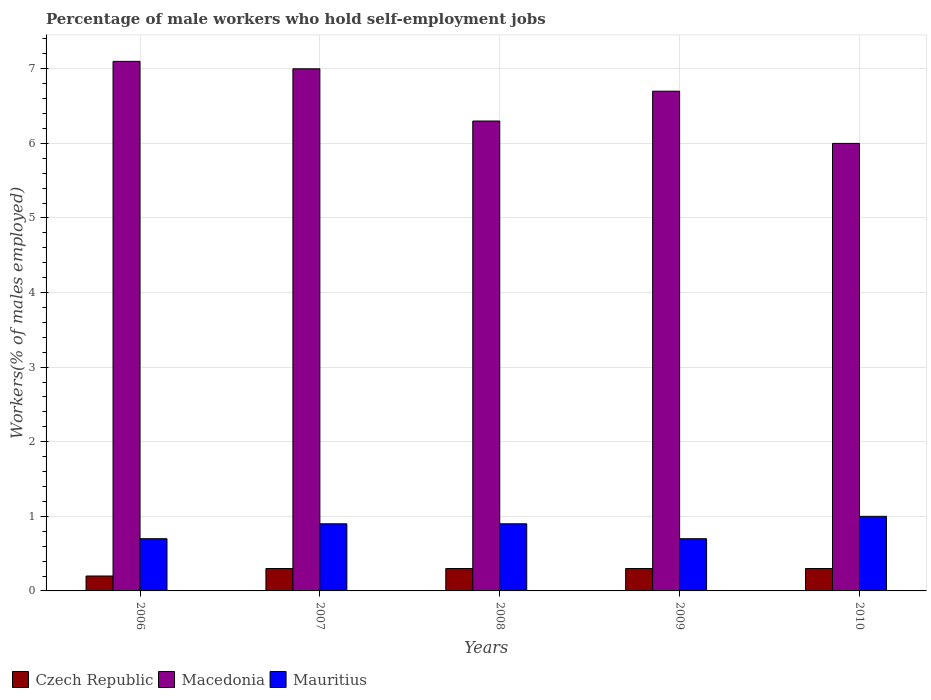How many different coloured bars are there?
Offer a very short reply. 3. Are the number of bars per tick equal to the number of legend labels?
Offer a very short reply. Yes. How many bars are there on the 3rd tick from the right?
Provide a short and direct response. 3. In how many cases, is the number of bars for a given year not equal to the number of legend labels?
Your answer should be very brief. 0. What is the percentage of self-employed male workers in Mauritius in 2009?
Give a very brief answer. 0.7. Across all years, what is the minimum percentage of self-employed male workers in Mauritius?
Your response must be concise. 0.7. In which year was the percentage of self-employed male workers in Czech Republic maximum?
Ensure brevity in your answer.  2007. In which year was the percentage of self-employed male workers in Czech Republic minimum?
Offer a terse response. 2006. What is the total percentage of self-employed male workers in Mauritius in the graph?
Ensure brevity in your answer.  4.2. What is the difference between the percentage of self-employed male workers in Czech Republic in 2006 and that in 2010?
Your response must be concise. -0.1. What is the difference between the percentage of self-employed male workers in Czech Republic in 2007 and the percentage of self-employed male workers in Macedonia in 2006?
Your answer should be compact. -6.8. What is the average percentage of self-employed male workers in Czech Republic per year?
Ensure brevity in your answer.  0.28. In the year 2006, what is the difference between the percentage of self-employed male workers in Czech Republic and percentage of self-employed male workers in Mauritius?
Keep it short and to the point. -0.5. In how many years, is the percentage of self-employed male workers in Macedonia greater than 6.4 %?
Offer a very short reply. 3. What is the ratio of the percentage of self-employed male workers in Mauritius in 2006 to that in 2010?
Your answer should be compact. 0.7. What is the difference between the highest and the lowest percentage of self-employed male workers in Macedonia?
Ensure brevity in your answer.  1.1. In how many years, is the percentage of self-employed male workers in Czech Republic greater than the average percentage of self-employed male workers in Czech Republic taken over all years?
Keep it short and to the point. 4. Is the sum of the percentage of self-employed male workers in Mauritius in 2009 and 2010 greater than the maximum percentage of self-employed male workers in Czech Republic across all years?
Give a very brief answer. Yes. What does the 1st bar from the left in 2010 represents?
Offer a terse response. Czech Republic. What does the 2nd bar from the right in 2009 represents?
Your answer should be compact. Macedonia. Is it the case that in every year, the sum of the percentage of self-employed male workers in Macedonia and percentage of self-employed male workers in Czech Republic is greater than the percentage of self-employed male workers in Mauritius?
Provide a short and direct response. Yes. How many bars are there?
Provide a succinct answer. 15. Are all the bars in the graph horizontal?
Make the answer very short. No. Are the values on the major ticks of Y-axis written in scientific E-notation?
Your response must be concise. No. Does the graph contain any zero values?
Offer a very short reply. No. How many legend labels are there?
Offer a very short reply. 3. What is the title of the graph?
Ensure brevity in your answer.  Percentage of male workers who hold self-employment jobs. What is the label or title of the Y-axis?
Your answer should be very brief. Workers(% of males employed). What is the Workers(% of males employed) of Czech Republic in 2006?
Provide a short and direct response. 0.2. What is the Workers(% of males employed) of Macedonia in 2006?
Keep it short and to the point. 7.1. What is the Workers(% of males employed) in Mauritius in 2006?
Offer a terse response. 0.7. What is the Workers(% of males employed) of Czech Republic in 2007?
Provide a short and direct response. 0.3. What is the Workers(% of males employed) of Mauritius in 2007?
Offer a terse response. 0.9. What is the Workers(% of males employed) of Czech Republic in 2008?
Give a very brief answer. 0.3. What is the Workers(% of males employed) in Macedonia in 2008?
Provide a short and direct response. 6.3. What is the Workers(% of males employed) in Mauritius in 2008?
Your answer should be compact. 0.9. What is the Workers(% of males employed) of Czech Republic in 2009?
Give a very brief answer. 0.3. What is the Workers(% of males employed) of Macedonia in 2009?
Make the answer very short. 6.7. What is the Workers(% of males employed) of Mauritius in 2009?
Give a very brief answer. 0.7. What is the Workers(% of males employed) in Czech Republic in 2010?
Offer a terse response. 0.3. What is the Workers(% of males employed) of Macedonia in 2010?
Offer a terse response. 6. What is the Workers(% of males employed) of Mauritius in 2010?
Make the answer very short. 1. Across all years, what is the maximum Workers(% of males employed) in Czech Republic?
Provide a succinct answer. 0.3. Across all years, what is the maximum Workers(% of males employed) in Macedonia?
Offer a terse response. 7.1. Across all years, what is the minimum Workers(% of males employed) in Czech Republic?
Offer a very short reply. 0.2. Across all years, what is the minimum Workers(% of males employed) in Mauritius?
Offer a very short reply. 0.7. What is the total Workers(% of males employed) in Czech Republic in the graph?
Provide a succinct answer. 1.4. What is the total Workers(% of males employed) in Macedonia in the graph?
Keep it short and to the point. 33.1. What is the total Workers(% of males employed) of Mauritius in the graph?
Your answer should be very brief. 4.2. What is the difference between the Workers(% of males employed) of Czech Republic in 2006 and that in 2007?
Provide a short and direct response. -0.1. What is the difference between the Workers(% of males employed) of Macedonia in 2006 and that in 2007?
Make the answer very short. 0.1. What is the difference between the Workers(% of males employed) of Czech Republic in 2006 and that in 2008?
Give a very brief answer. -0.1. What is the difference between the Workers(% of males employed) in Czech Republic in 2006 and that in 2009?
Make the answer very short. -0.1. What is the difference between the Workers(% of males employed) in Macedonia in 2006 and that in 2009?
Give a very brief answer. 0.4. What is the difference between the Workers(% of males employed) in Czech Republic in 2006 and that in 2010?
Offer a terse response. -0.1. What is the difference between the Workers(% of males employed) of Macedonia in 2006 and that in 2010?
Make the answer very short. 1.1. What is the difference between the Workers(% of males employed) of Mauritius in 2006 and that in 2010?
Provide a succinct answer. -0.3. What is the difference between the Workers(% of males employed) of Macedonia in 2007 and that in 2008?
Your answer should be compact. 0.7. What is the difference between the Workers(% of males employed) of Mauritius in 2007 and that in 2008?
Make the answer very short. 0. What is the difference between the Workers(% of males employed) in Czech Republic in 2007 and that in 2010?
Provide a succinct answer. 0. What is the difference between the Workers(% of males employed) in Macedonia in 2007 and that in 2010?
Provide a succinct answer. 1. What is the difference between the Workers(% of males employed) in Czech Republic in 2008 and that in 2009?
Give a very brief answer. 0. What is the difference between the Workers(% of males employed) of Macedonia in 2008 and that in 2009?
Give a very brief answer. -0.4. What is the difference between the Workers(% of males employed) in Mauritius in 2008 and that in 2009?
Keep it short and to the point. 0.2. What is the difference between the Workers(% of males employed) of Macedonia in 2008 and that in 2010?
Keep it short and to the point. 0.3. What is the difference between the Workers(% of males employed) in Czech Republic in 2006 and the Workers(% of males employed) in Macedonia in 2007?
Provide a short and direct response. -6.8. What is the difference between the Workers(% of males employed) in Czech Republic in 2006 and the Workers(% of males employed) in Mauritius in 2008?
Provide a short and direct response. -0.7. What is the difference between the Workers(% of males employed) of Czech Republic in 2006 and the Workers(% of males employed) of Macedonia in 2009?
Provide a succinct answer. -6.5. What is the difference between the Workers(% of males employed) in Czech Republic in 2006 and the Workers(% of males employed) in Mauritius in 2009?
Your response must be concise. -0.5. What is the difference between the Workers(% of males employed) of Macedonia in 2006 and the Workers(% of males employed) of Mauritius in 2009?
Give a very brief answer. 6.4. What is the difference between the Workers(% of males employed) in Czech Republic in 2006 and the Workers(% of males employed) in Mauritius in 2010?
Give a very brief answer. -0.8. What is the difference between the Workers(% of males employed) of Macedonia in 2006 and the Workers(% of males employed) of Mauritius in 2010?
Your answer should be very brief. 6.1. What is the difference between the Workers(% of males employed) in Czech Republic in 2007 and the Workers(% of males employed) in Macedonia in 2008?
Ensure brevity in your answer.  -6. What is the difference between the Workers(% of males employed) of Czech Republic in 2007 and the Workers(% of males employed) of Macedonia in 2009?
Keep it short and to the point. -6.4. What is the difference between the Workers(% of males employed) of Czech Republic in 2007 and the Workers(% of males employed) of Mauritius in 2009?
Offer a very short reply. -0.4. What is the difference between the Workers(% of males employed) of Czech Republic in 2007 and the Workers(% of males employed) of Macedonia in 2010?
Give a very brief answer. -5.7. What is the difference between the Workers(% of males employed) of Czech Republic in 2007 and the Workers(% of males employed) of Mauritius in 2010?
Ensure brevity in your answer.  -0.7. What is the difference between the Workers(% of males employed) in Macedonia in 2007 and the Workers(% of males employed) in Mauritius in 2010?
Offer a terse response. 6. What is the difference between the Workers(% of males employed) of Czech Republic in 2008 and the Workers(% of males employed) of Macedonia in 2009?
Provide a succinct answer. -6.4. What is the difference between the Workers(% of males employed) of Czech Republic in 2008 and the Workers(% of males employed) of Macedonia in 2010?
Ensure brevity in your answer.  -5.7. What is the difference between the Workers(% of males employed) of Czech Republic in 2009 and the Workers(% of males employed) of Mauritius in 2010?
Your answer should be very brief. -0.7. What is the difference between the Workers(% of males employed) of Macedonia in 2009 and the Workers(% of males employed) of Mauritius in 2010?
Your answer should be compact. 5.7. What is the average Workers(% of males employed) of Czech Republic per year?
Your response must be concise. 0.28. What is the average Workers(% of males employed) of Macedonia per year?
Provide a succinct answer. 6.62. What is the average Workers(% of males employed) in Mauritius per year?
Provide a short and direct response. 0.84. In the year 2006, what is the difference between the Workers(% of males employed) in Czech Republic and Workers(% of males employed) in Macedonia?
Your response must be concise. -6.9. In the year 2006, what is the difference between the Workers(% of males employed) of Macedonia and Workers(% of males employed) of Mauritius?
Give a very brief answer. 6.4. In the year 2007, what is the difference between the Workers(% of males employed) in Czech Republic and Workers(% of males employed) in Mauritius?
Provide a short and direct response. -0.6. In the year 2008, what is the difference between the Workers(% of males employed) in Czech Republic and Workers(% of males employed) in Mauritius?
Offer a terse response. -0.6. In the year 2009, what is the difference between the Workers(% of males employed) in Czech Republic and Workers(% of males employed) in Macedonia?
Make the answer very short. -6.4. In the year 2010, what is the difference between the Workers(% of males employed) in Czech Republic and Workers(% of males employed) in Mauritius?
Keep it short and to the point. -0.7. In the year 2010, what is the difference between the Workers(% of males employed) in Macedonia and Workers(% of males employed) in Mauritius?
Make the answer very short. 5. What is the ratio of the Workers(% of males employed) in Czech Republic in 2006 to that in 2007?
Give a very brief answer. 0.67. What is the ratio of the Workers(% of males employed) of Macedonia in 2006 to that in 2007?
Keep it short and to the point. 1.01. What is the ratio of the Workers(% of males employed) in Czech Republic in 2006 to that in 2008?
Offer a very short reply. 0.67. What is the ratio of the Workers(% of males employed) in Macedonia in 2006 to that in 2008?
Provide a succinct answer. 1.13. What is the ratio of the Workers(% of males employed) of Czech Republic in 2006 to that in 2009?
Your answer should be compact. 0.67. What is the ratio of the Workers(% of males employed) in Macedonia in 2006 to that in 2009?
Make the answer very short. 1.06. What is the ratio of the Workers(% of males employed) in Macedonia in 2006 to that in 2010?
Your answer should be compact. 1.18. What is the ratio of the Workers(% of males employed) of Mauritius in 2006 to that in 2010?
Offer a very short reply. 0.7. What is the ratio of the Workers(% of males employed) of Macedonia in 2007 to that in 2008?
Give a very brief answer. 1.11. What is the ratio of the Workers(% of males employed) in Mauritius in 2007 to that in 2008?
Offer a very short reply. 1. What is the ratio of the Workers(% of males employed) in Macedonia in 2007 to that in 2009?
Offer a very short reply. 1.04. What is the ratio of the Workers(% of males employed) of Mauritius in 2007 to that in 2009?
Offer a very short reply. 1.29. What is the ratio of the Workers(% of males employed) in Macedonia in 2007 to that in 2010?
Ensure brevity in your answer.  1.17. What is the ratio of the Workers(% of males employed) of Macedonia in 2008 to that in 2009?
Offer a terse response. 0.94. What is the ratio of the Workers(% of males employed) of Czech Republic in 2008 to that in 2010?
Offer a terse response. 1. What is the ratio of the Workers(% of males employed) in Macedonia in 2008 to that in 2010?
Your answer should be compact. 1.05. What is the ratio of the Workers(% of males employed) in Mauritius in 2008 to that in 2010?
Your answer should be very brief. 0.9. What is the ratio of the Workers(% of males employed) of Macedonia in 2009 to that in 2010?
Offer a terse response. 1.12. What is the difference between the highest and the second highest Workers(% of males employed) of Czech Republic?
Ensure brevity in your answer.  0. What is the difference between the highest and the lowest Workers(% of males employed) in Czech Republic?
Make the answer very short. 0.1. What is the difference between the highest and the lowest Workers(% of males employed) in Macedonia?
Offer a terse response. 1.1. What is the difference between the highest and the lowest Workers(% of males employed) in Mauritius?
Your response must be concise. 0.3. 